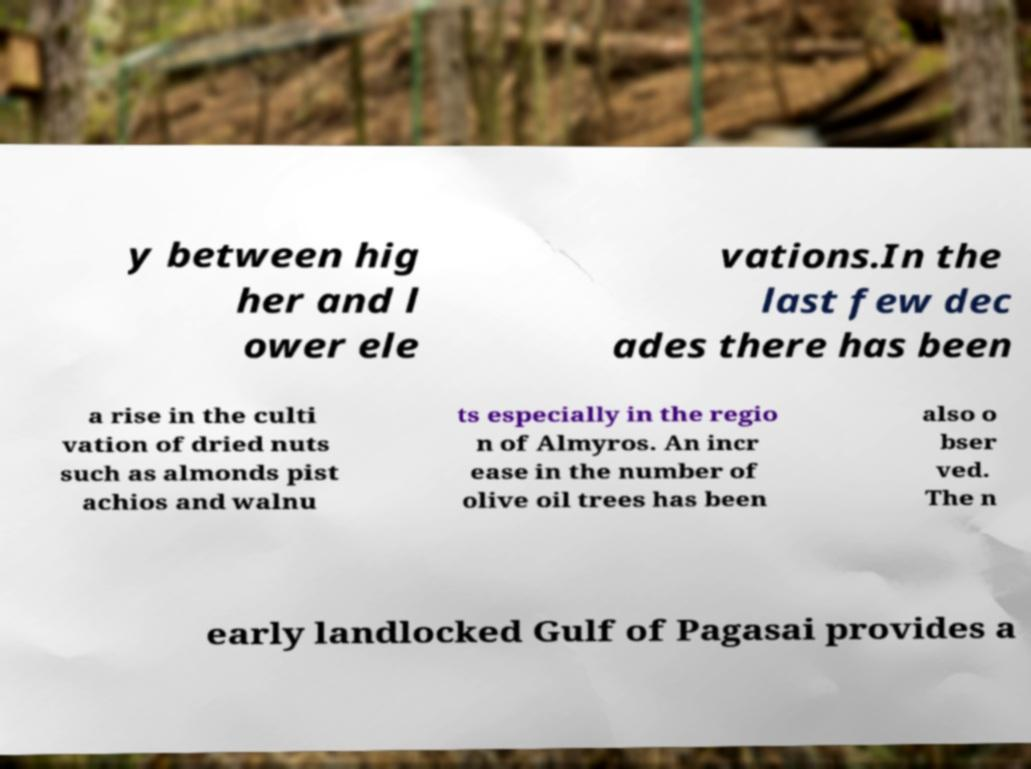For documentation purposes, I need the text within this image transcribed. Could you provide that? y between hig her and l ower ele vations.In the last few dec ades there has been a rise in the culti vation of dried nuts such as almonds pist achios and walnu ts especially in the regio n of Almyros. An incr ease in the number of olive oil trees has been also o bser ved. The n early landlocked Gulf of Pagasai provides a 